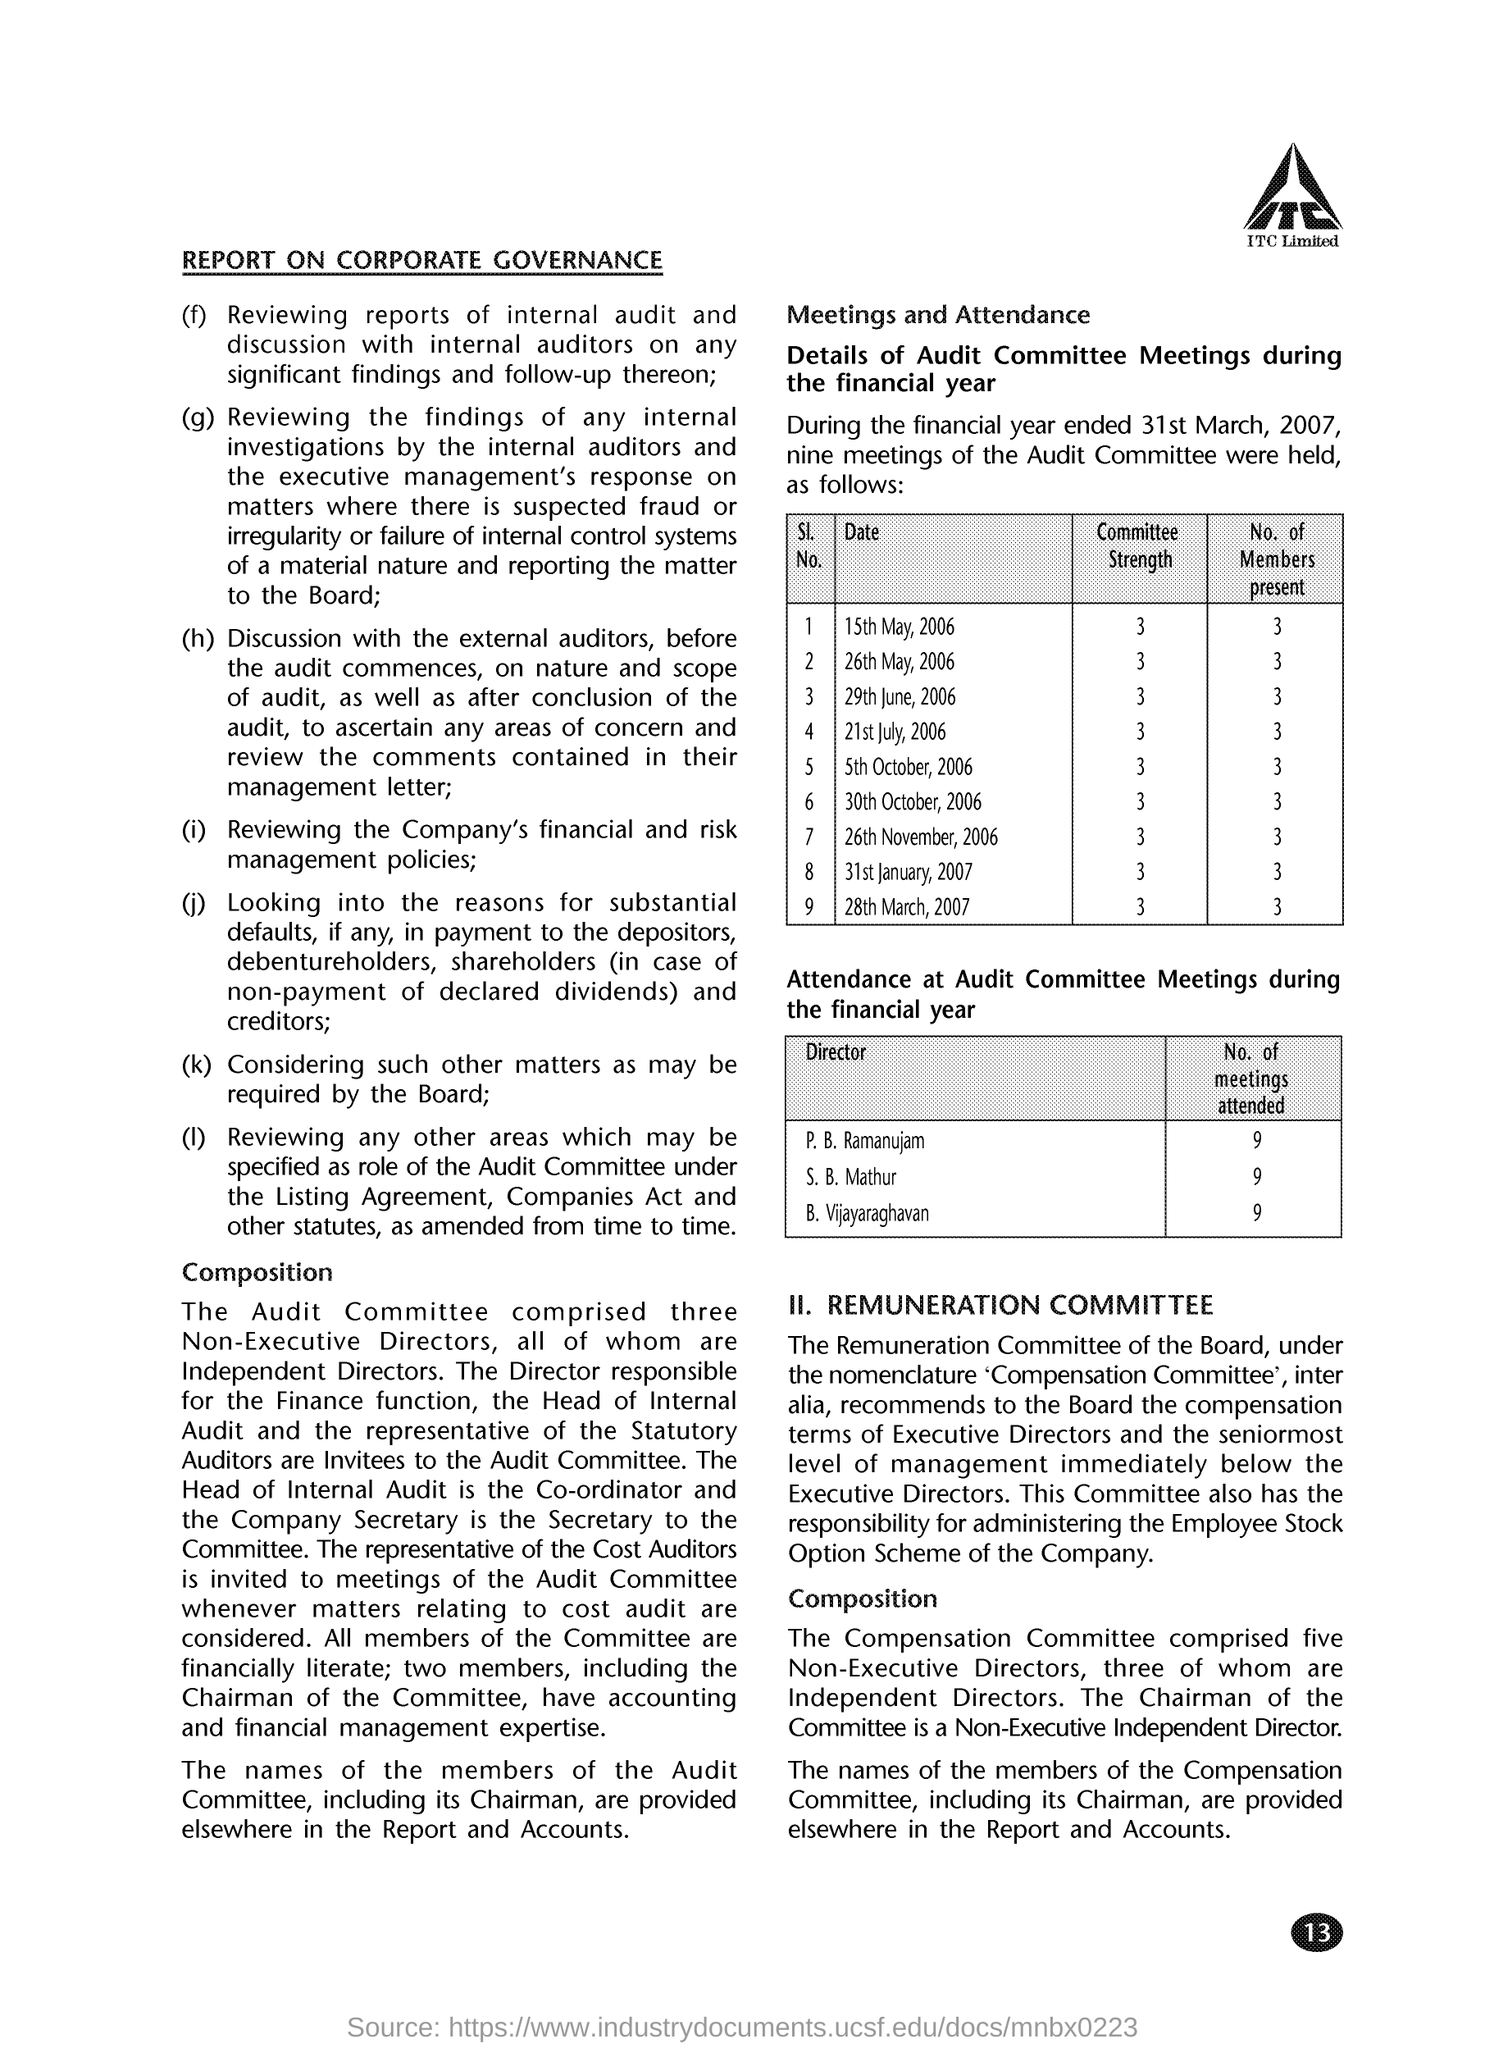How many Audit Committee Meetings are attended by S. B. Mathur during the financial year ended on 31st March, 2007?
Give a very brief answer. 9. How many Audit Committee Meetings are attended by B. Vijayaraghavan during the financial year ended on 31st March, 2007?
Your response must be concise. 9. How many members were present for the Audit Committee Meetings held on 15th May, 2006?
Your response must be concise. 3. How many members were present for the Audit Committee Meetings held on 21st July, 2006?
Your response must be concise. 3. Who is invited to the Audit Committee Meetings whenever matters relating to cost audit are considered?
Your answer should be compact. The representative of the Cost Auditors. What is the page no mentioned in this document?
Your response must be concise. 13. 